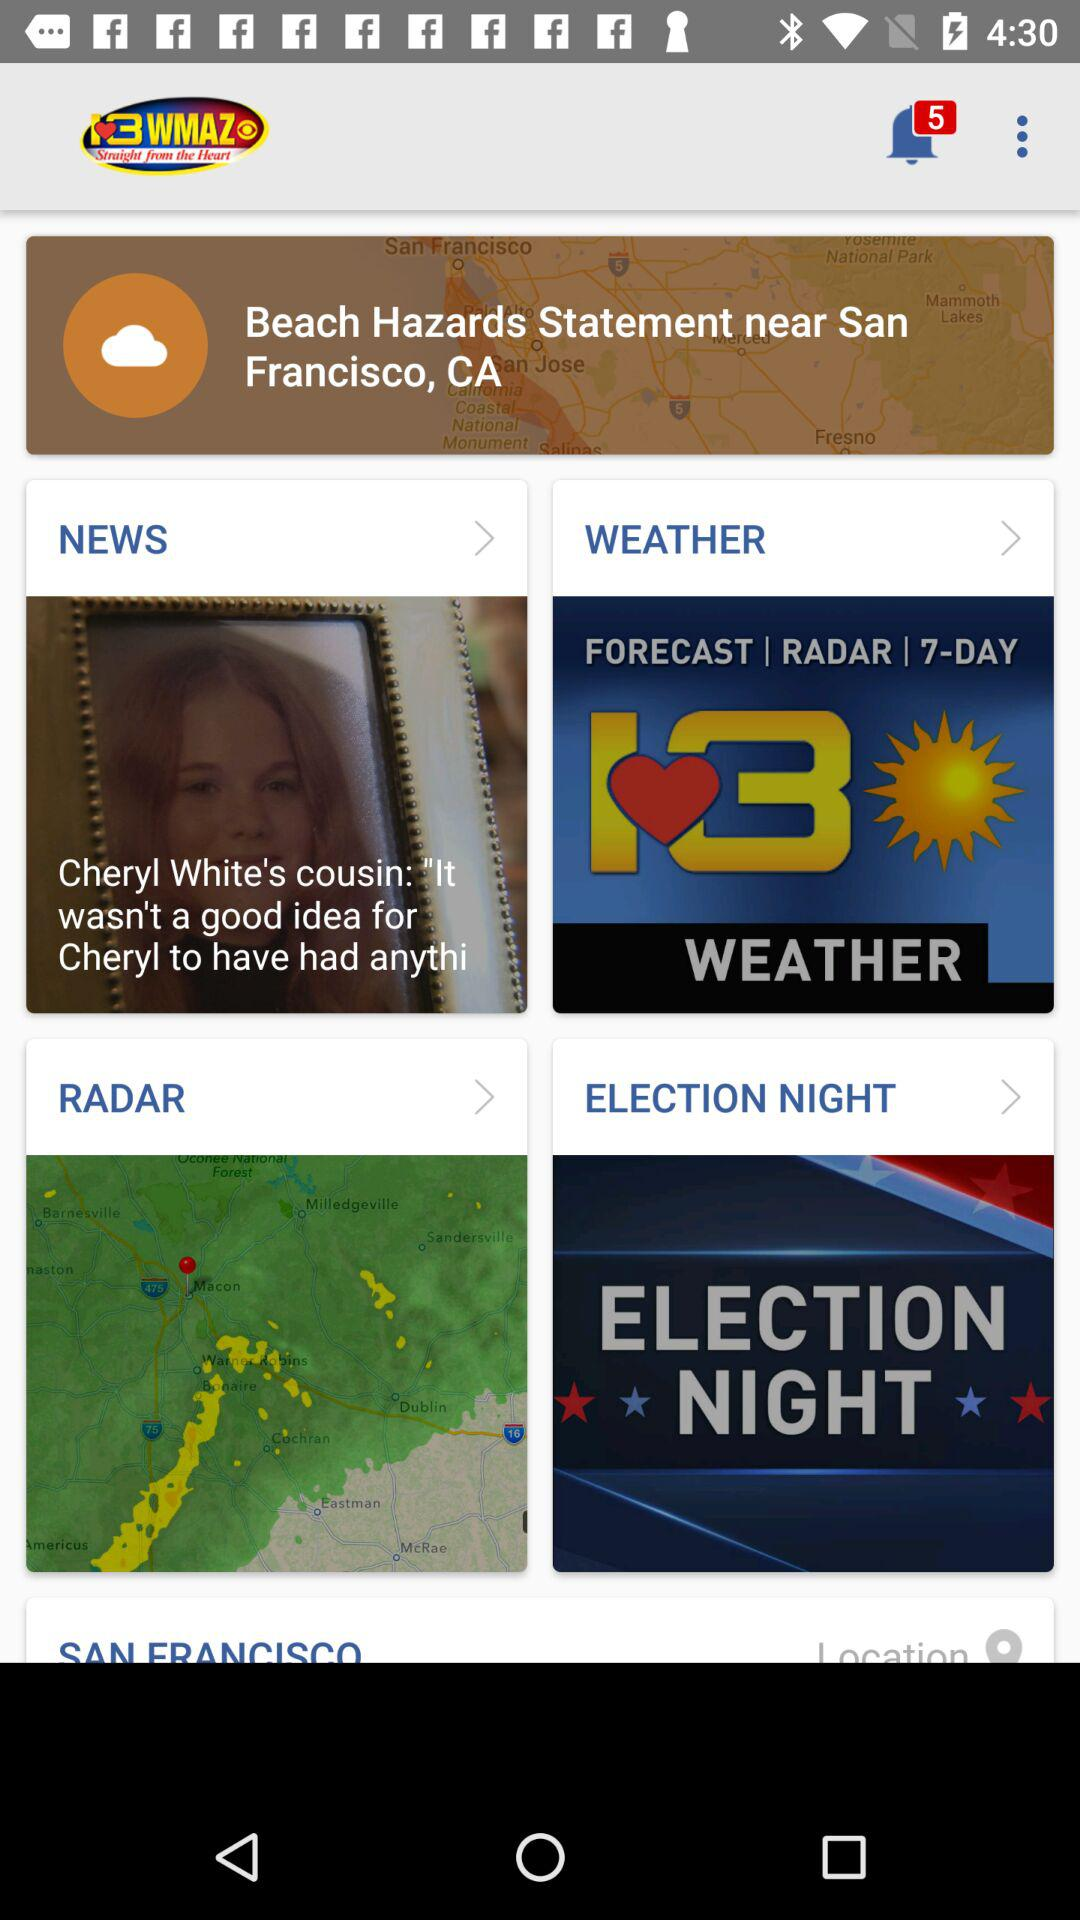How many unread notifications are there? There are 5 unread notifications. 